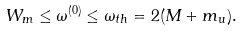Convert formula to latex. <formula><loc_0><loc_0><loc_500><loc_500>W _ { m } \leq \omega ^ { ( 0 ) } \leq \omega _ { t h } = 2 ( M + m _ { u } ) .</formula> 